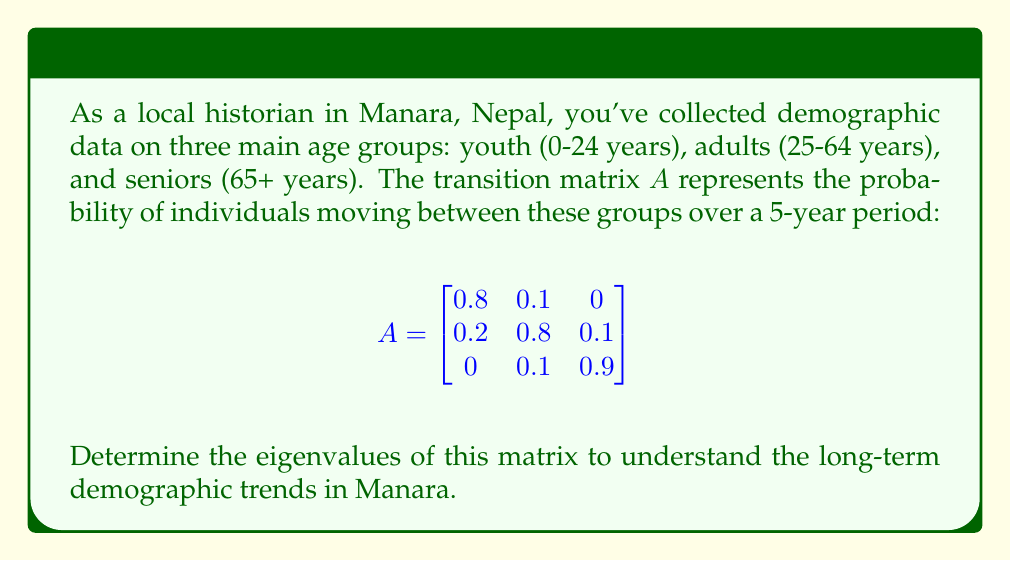Help me with this question. To find the eigenvalues of matrix $A$, we need to solve the characteristic equation:

$det(A - \lambda I) = 0$

where $\lambda$ represents the eigenvalues and $I$ is the $3 \times 3$ identity matrix.

Step 1: Set up the characteristic equation:
$$det\begin{pmatrix}
0.8 - \lambda & 0.1 & 0 \\
0.2 & 0.8 - \lambda & 0.1 \\
0 & 0.1 & 0.9 - \lambda
\end{pmatrix} = 0$$

Step 2: Expand the determinant:
$$(0.8 - \lambda)[(0.8 - \lambda)(0.9 - \lambda) - 0.01] - 0.1[0.2(0.9 - \lambda) - 0(0.1)] = 0$$

Step 3: Simplify:
$$(0.8 - \lambda)(0.72 - 1.7\lambda + \lambda^2) - 0.1(0.18 - 0.2\lambda) = 0$$
$$0.576 - 1.36\lambda + 0.8\lambda^2 - 0.72\lambda + 1.7\lambda^2 - \lambda^3 - 0.018 + 0.02\lambda = 0$$

Step 4: Collect terms:
$$-\lambda^3 + 2.5\lambda^2 - 2.06\lambda + 0.558 = 0$$

Step 5: Solve the cubic equation. This can be done using the cubic formula or numerical methods. The solutions are:

$\lambda_1 = 1$
$\lambda_2 \approx 0.8$
$\lambda_3 \approx 0.7$

These eigenvalues represent the long-term growth rates for different demographic components in Manara.
Answer: $\lambda_1 = 1$, $\lambda_2 \approx 0.8$, $\lambda_3 \approx 0.7$ 